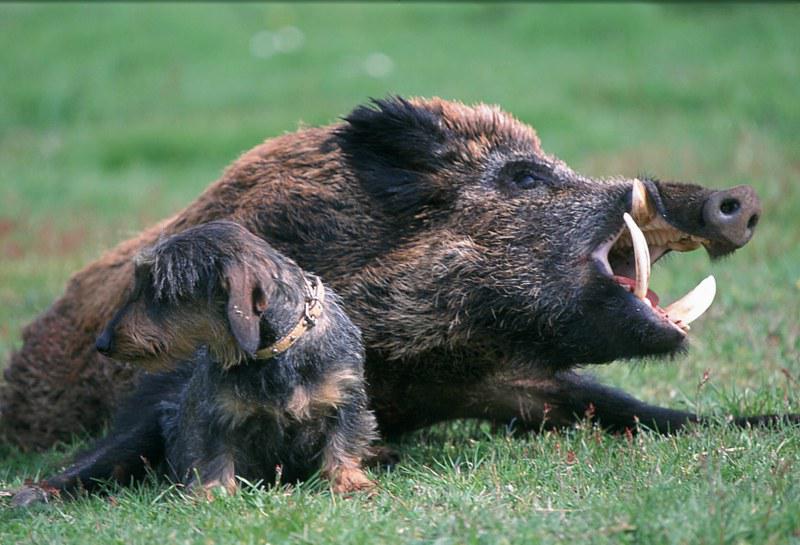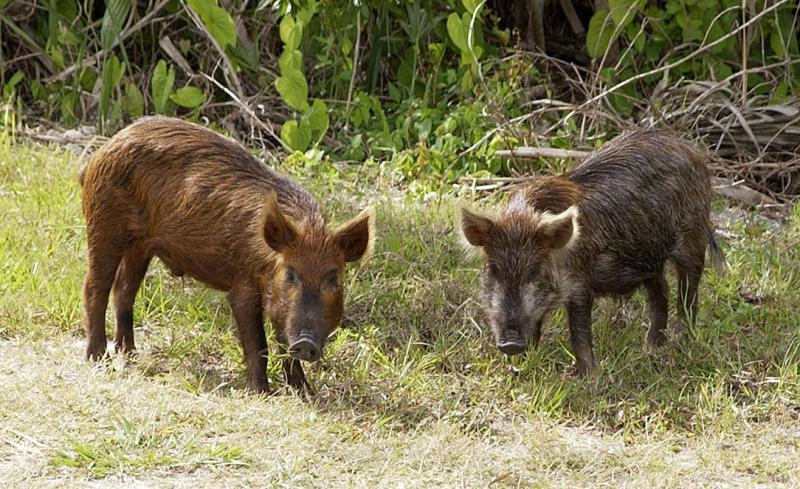The first image is the image on the left, the second image is the image on the right. Examine the images to the left and right. Is the description "An image includes at least one tusked boar lying on the ground, and at least one other kind of mammal in the picture." accurate? Answer yes or no. Yes. The first image is the image on the left, the second image is the image on the right. Examine the images to the left and right. Is the description "The right image contains exactly two pigs." accurate? Answer yes or no. Yes. 